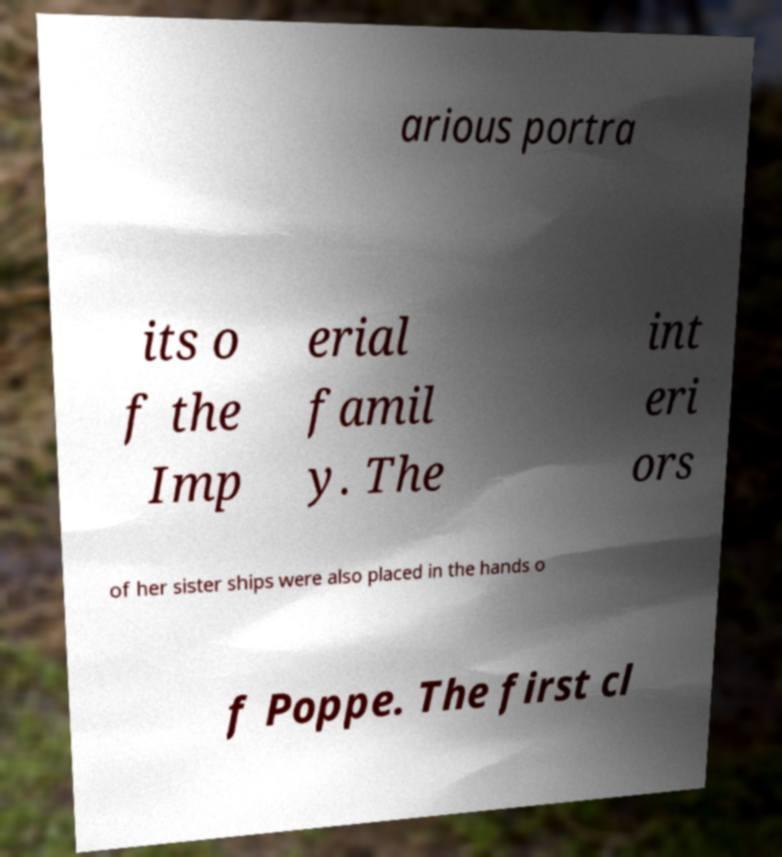For documentation purposes, I need the text within this image transcribed. Could you provide that? arious portra its o f the Imp erial famil y. The int eri ors of her sister ships were also placed in the hands o f Poppe. The first cl 